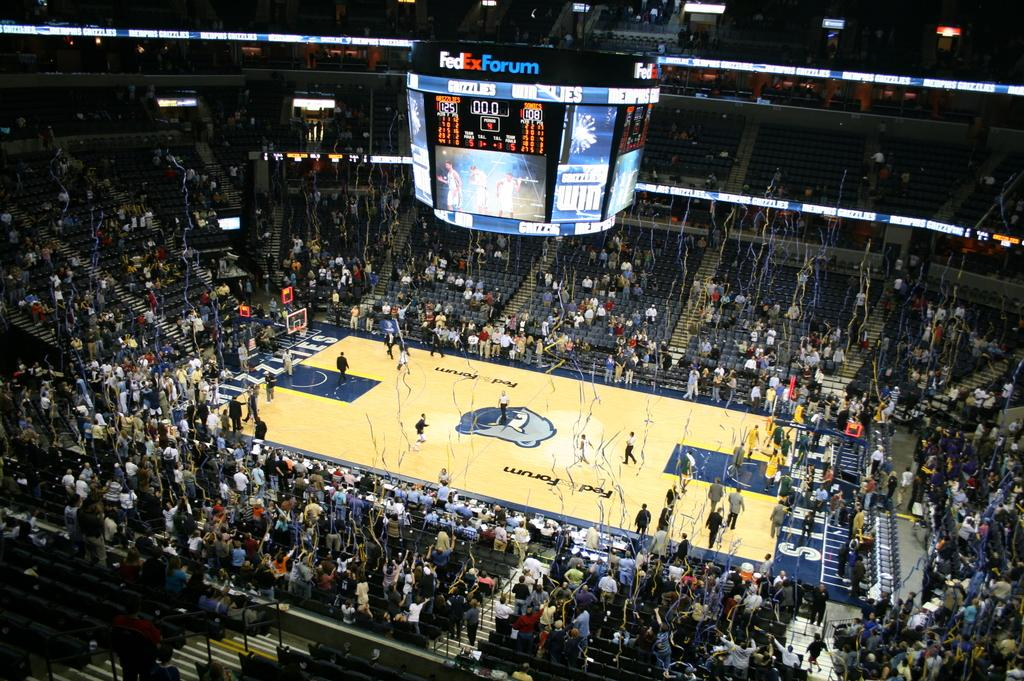<image>
Summarize the visual content of the image. A scoreboard hanging from a stadium celing with the words Fedex Forum. 